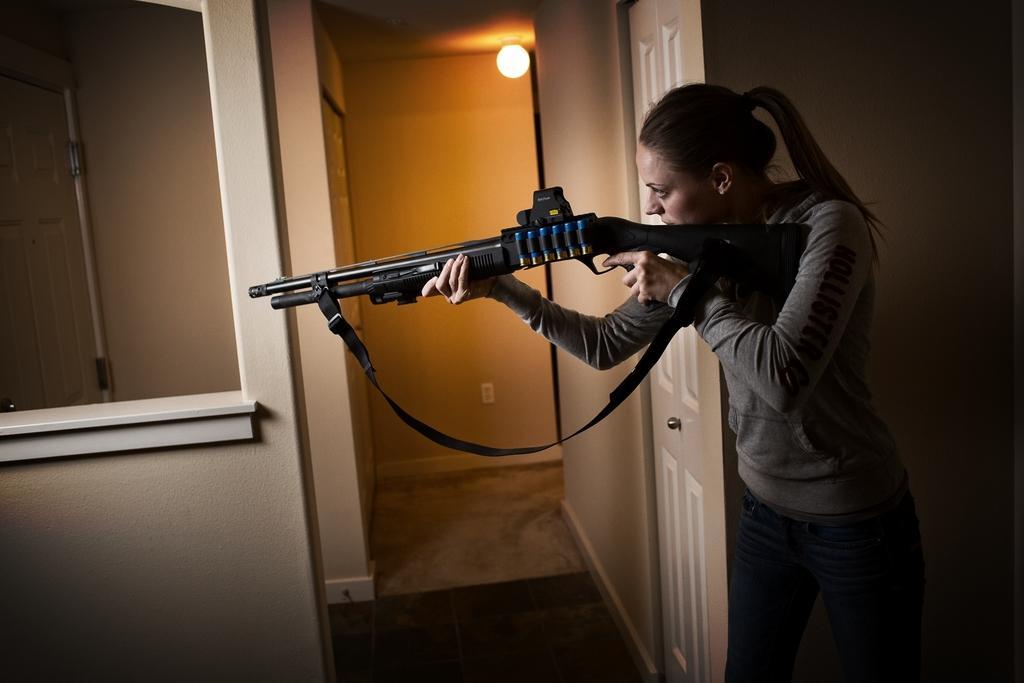Can you describe this image briefly? On the right side, there is a woman in gray color t-shirt, standing, holding a gun and watching something. Beside her, there is a wall. On the left side, there is a wall. In the background, there is a light attached to the roof and there is a wall. 